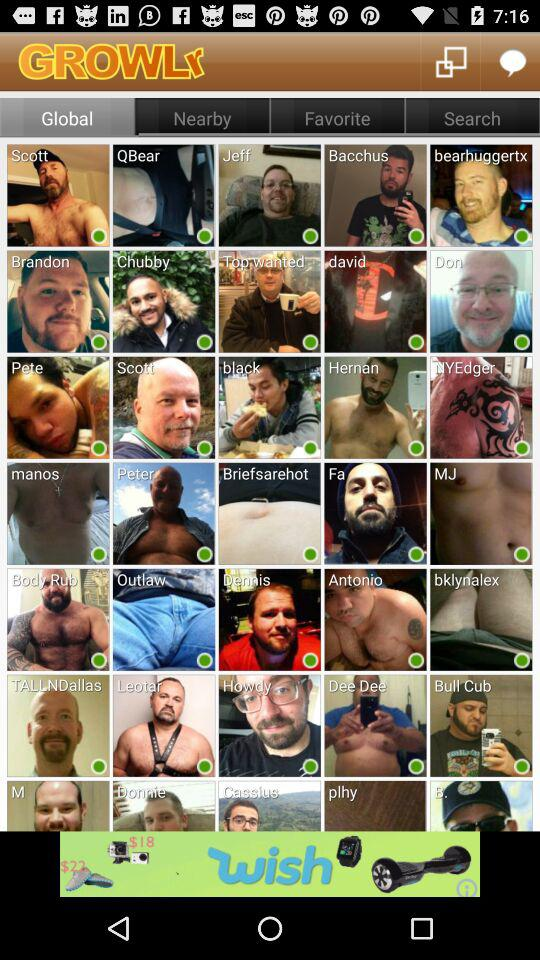Which tab has been selected? The selected tab is "Global". 